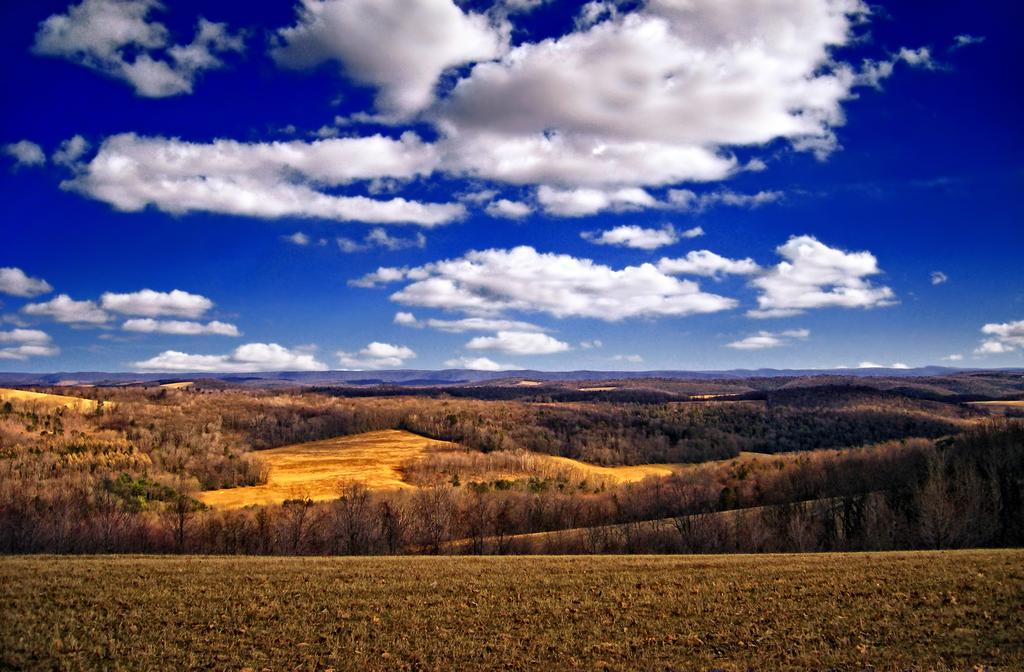What type of vegetation can be seen in the image? There are many trees and plants in the image. What can be seen in the sky in the image? The sky is blue and slightly cloudy in the image. How many brothers are playing with the cats on the wrist in the image? There are no brothers, cats, or wrists present in the image. 